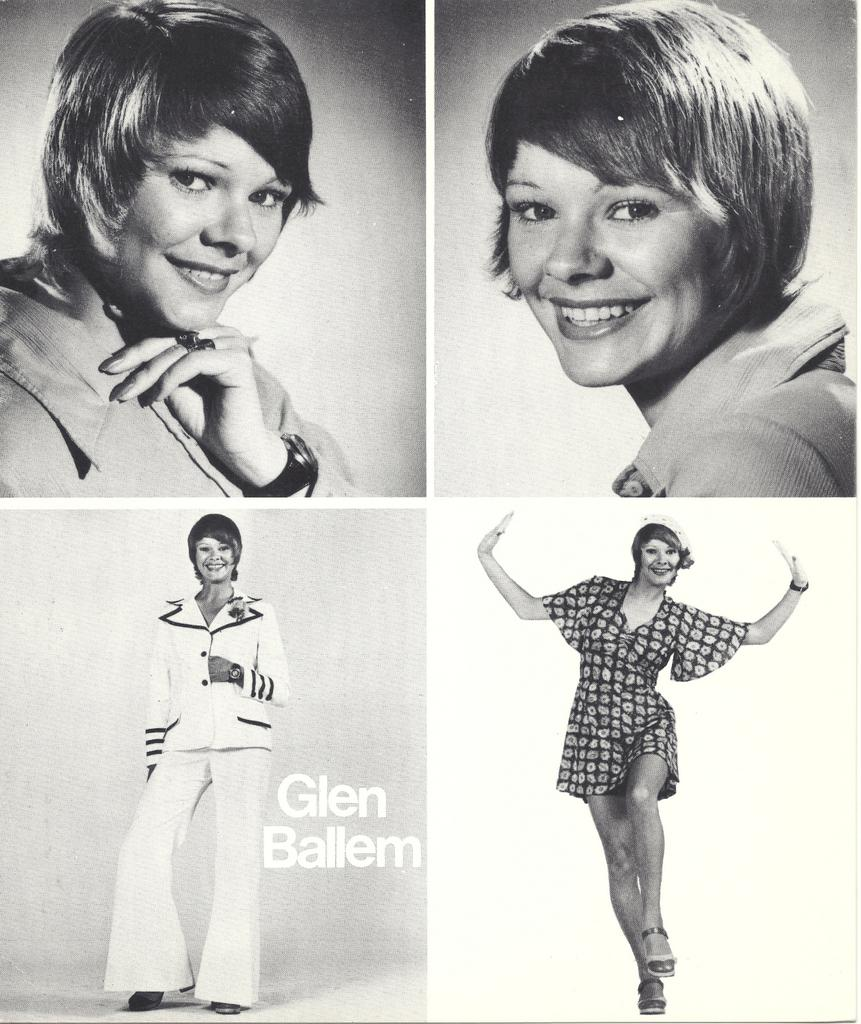What is the position of the woman on the left side of the image? There is a woman on the left side of the image. What is the woman on the left side of the image doing? The woman on the left side is smiling. What is the position of the woman on the right side of the image? There is a woman on the right side of the image. What is the woman on the right side of the image doing? The woman on the right side is jumping. How is the image composed? The image is a photo collage. What type of badge is the woman on the left side wearing in the image? There is no badge visible on the woman on the left side in the image. What does the woman's mom say about her jumping in the image? There is no reference to the woman's mom or her opinion in the image. 